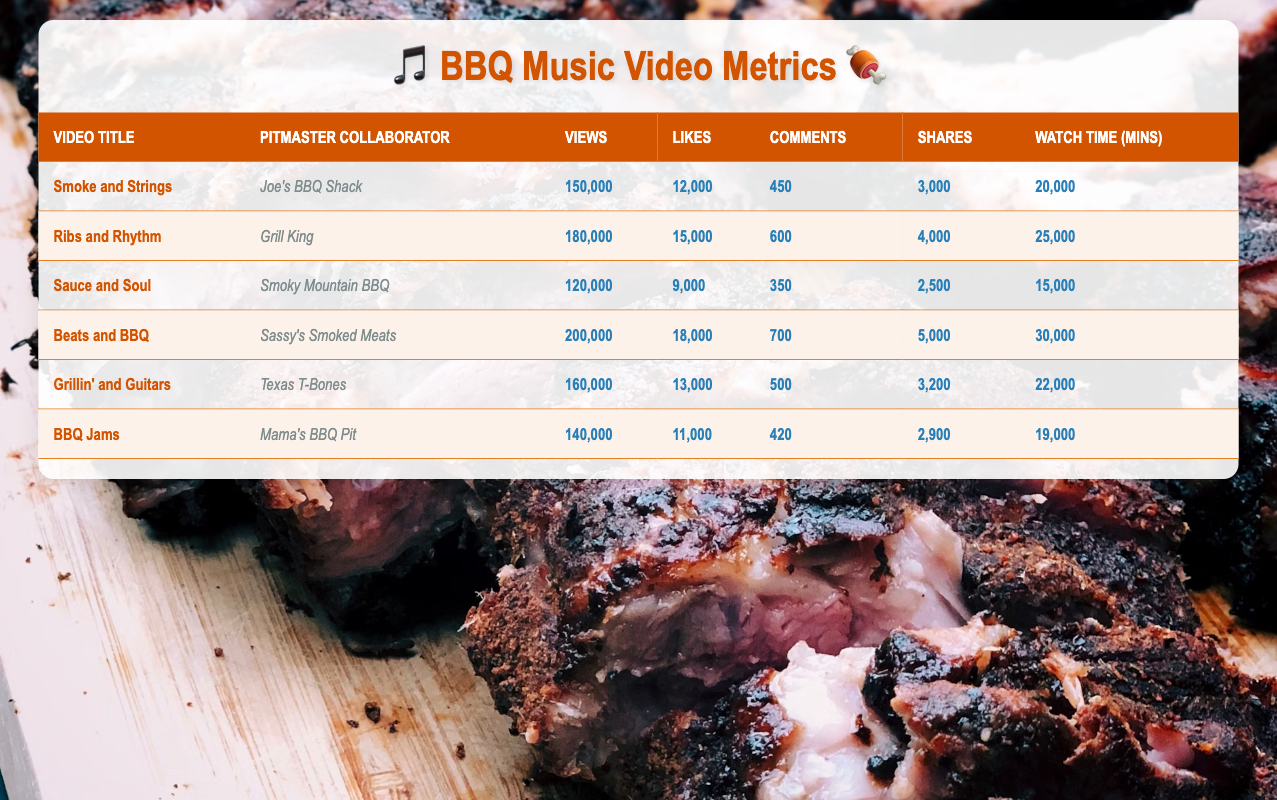What is the title of the video with the highest number of views? The video with the highest number of views in the table is identified by comparing the "Views" column. The video "Beats and BBQ" has the highest views at 200,000.
Answer: Beats and BBQ Which pitmaster collaborated on the video "Ribs and Rhythm"? By looking at the "Video Title" column, we can see that the video "Ribs and Rhythm" is associated with "Grill King" in the "Pitmaster Collaborator" column.
Answer: Grill King What is the total number of likes across all videos? To calculate the total likes, we need to sum up the likes from each video: 12,000 + 15,000 + 9,000 + 18,000 + 13,000 + 11,000 = 78,000.
Answer: 78,000 Does the video "Sauce and Soul" have more comments than the video "Smoke and Strings"? We compare their respective comments: "Sauce and Soul" has 350 comments, while "Smoke and Strings" has 450. Since 350 is less than 450, the statement is false.
Answer: No What is the average watch time in minutes for the videos collaborated with local pitmasters? To find the average, we first sum the watch times: 20,000 + 25,000 + 15,000 + 30,000 + 22,000 + 19,000 = 131,000. There are 6 videos, so the average watch time is 131,000 / 6 = 21,833.33.
Answer: 21,833.33 Which video has the second highest number of shares? We need to sort the "Shares" column to find the second highest. The shares for each video are 3,000, 4,000, 2,500, 5,000, 3,200, and 2,900. Sorting in descending order gives us: 5,000, 4,000, 3,200, 3,000, 2,900, 2,500. Therefore, the second highest is "Ribs and Rhythm" with 4,000 shares.
Answer: Ribs and Rhythm Is the number of views for "BBQ Jams" greater than or equal to the combined views of "Smoke and Strings" and "Sauce and Soul"? We compare: "BBQ Jams" has 140,000 views. For the combination: "Smoke and Strings" has 150,000 and "Sauce and Soul" has 120,000, totaling 270,000. Since 140,000 is less than 270,000, the statement is false.
Answer: No 